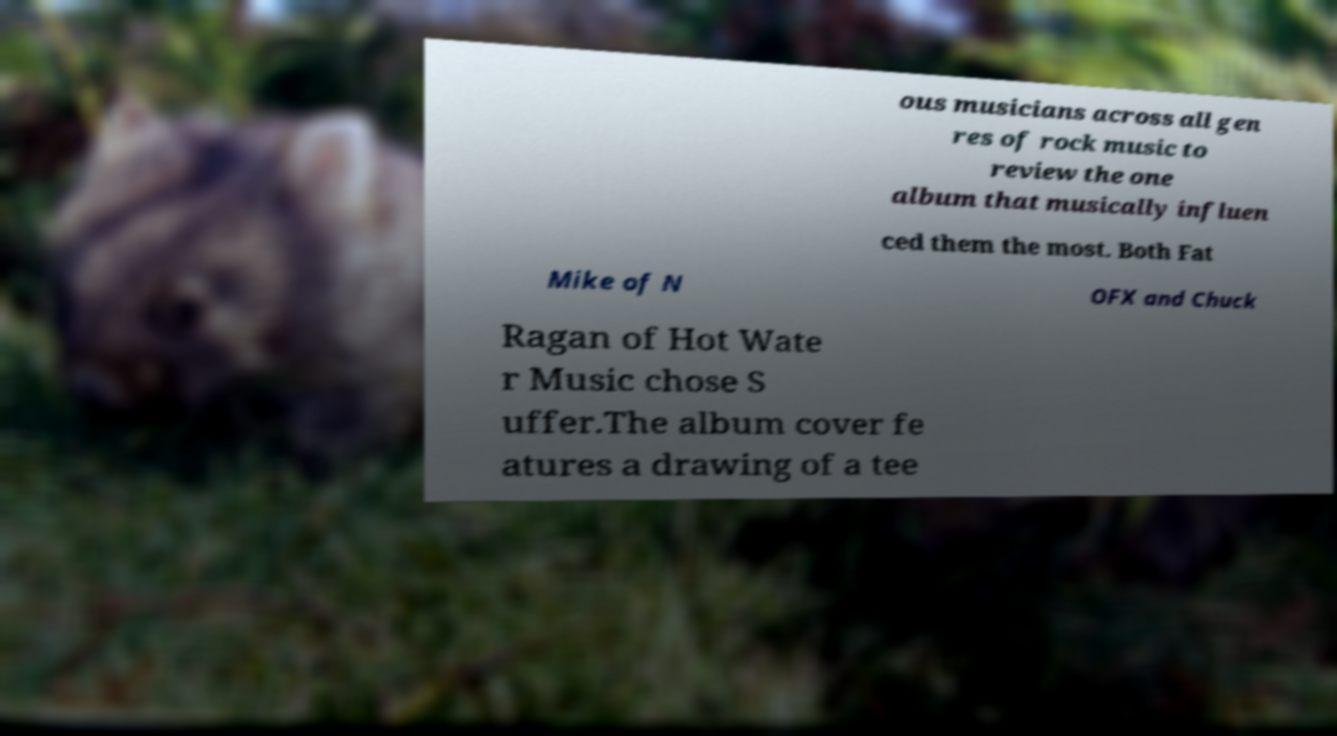What messages or text are displayed in this image? I need them in a readable, typed format. ous musicians across all gen res of rock music to review the one album that musically influen ced them the most. Both Fat Mike of N OFX and Chuck Ragan of Hot Wate r Music chose S uffer.The album cover fe atures a drawing of a tee 